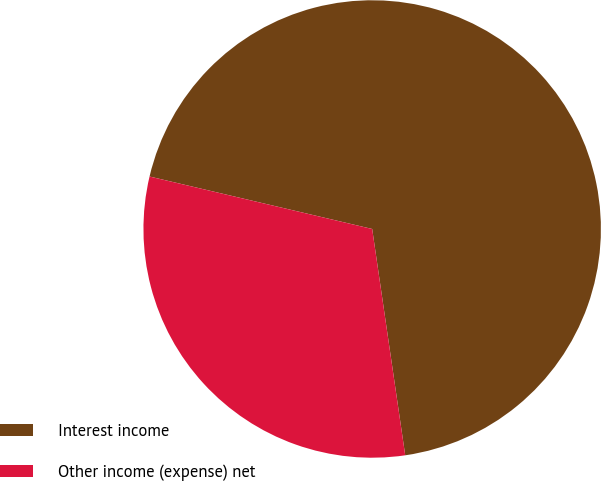<chart> <loc_0><loc_0><loc_500><loc_500><pie_chart><fcel>Interest income<fcel>Other income (expense) net<nl><fcel>69.01%<fcel>30.99%<nl></chart> 